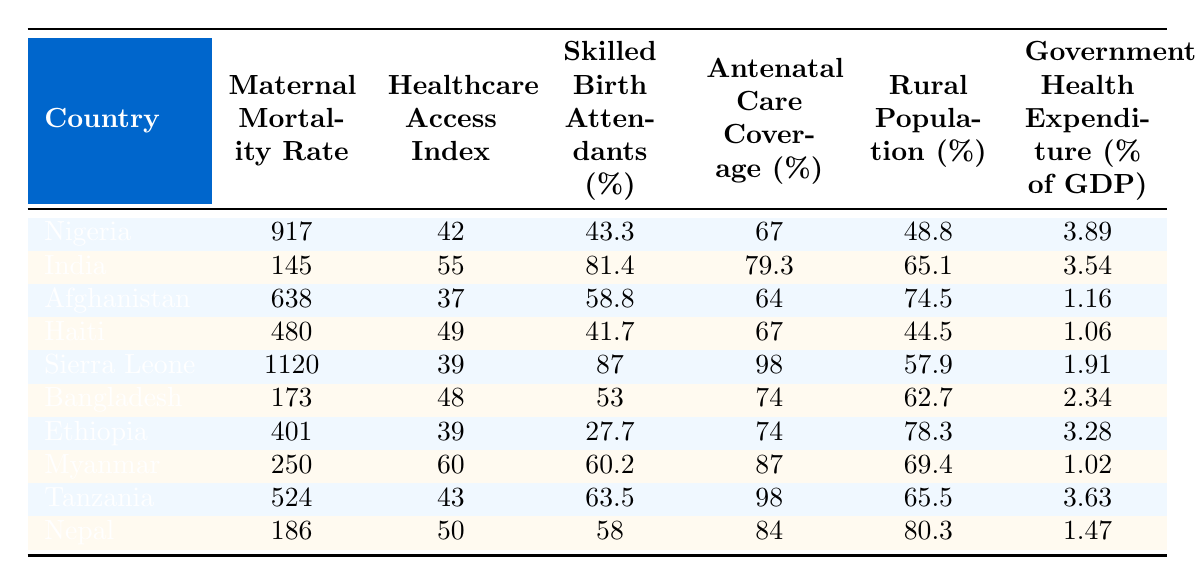What is the maternal mortality rate in Nigeria? According to the table, the maternal mortality rate listed for Nigeria is 917 per 100,000 live births.
Answer: 917 Which country has the highest healthcare access index? By examining the Healthcare Access Index column, India has the highest access index at 55 out of 100.
Answer: India What percentage of skilled birth attendants is there in Sierra Leone? The table shows that Sierra Leone has 87% of skilled birth attendants.
Answer: 87% Is the antenatal care coverage in Ethiopia above 70%? The antenatal care coverage for Ethiopia is 74%, which is above 70%.
Answer: Yes What is the difference in maternal mortality rates between India and Bangladesh? India’s maternal mortality rate is 145, while Bangladesh’s is 173. The difference is 173 - 145 = 28.
Answer: 28 Which country has the lowest government health expenditure as a percentage of GDP? Reviewing the table, Afghanistan has the lowest government health expenditure at 1.16% of GDP.
Answer: Afghanistan Compute the average maternal mortality rate of countries listed with healthcare access index below 45. The countries with an index below 45 are Nigeria (917), Afghanistan (638), and Sierra Leone (1120). The sum is (917 + 638 + 1120) = 2675, and the average is 2675 / 3 = 891.67.
Answer: 891.67 Is the rural population percentage higher in Nepal than in Haiti? The rural population percentage for Nepal is 80.3%, and for Haiti, it is 44.5%. Since 80.3% > 44.5%, the answer is yes.
Answer: Yes Which country has the highest maternal mortality rate, and what is it? The highest maternal mortality rate is in Sierra Leone at 1120 per 100,000 live births.
Answer: Sierra Leone, 1120 What percentage of the population is rural in Tanzania? The table indicates that the rural population percentage in Tanzania is 65.5%.
Answer: 65.5% 